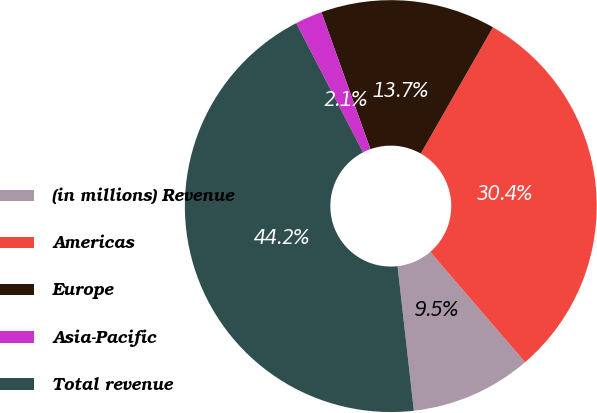Convert chart to OTSL. <chart><loc_0><loc_0><loc_500><loc_500><pie_chart><fcel>(in millions) Revenue<fcel>Americas<fcel>Europe<fcel>Asia-Pacific<fcel>Total revenue<nl><fcel>9.52%<fcel>30.43%<fcel>13.73%<fcel>2.12%<fcel>44.19%<nl></chart> 